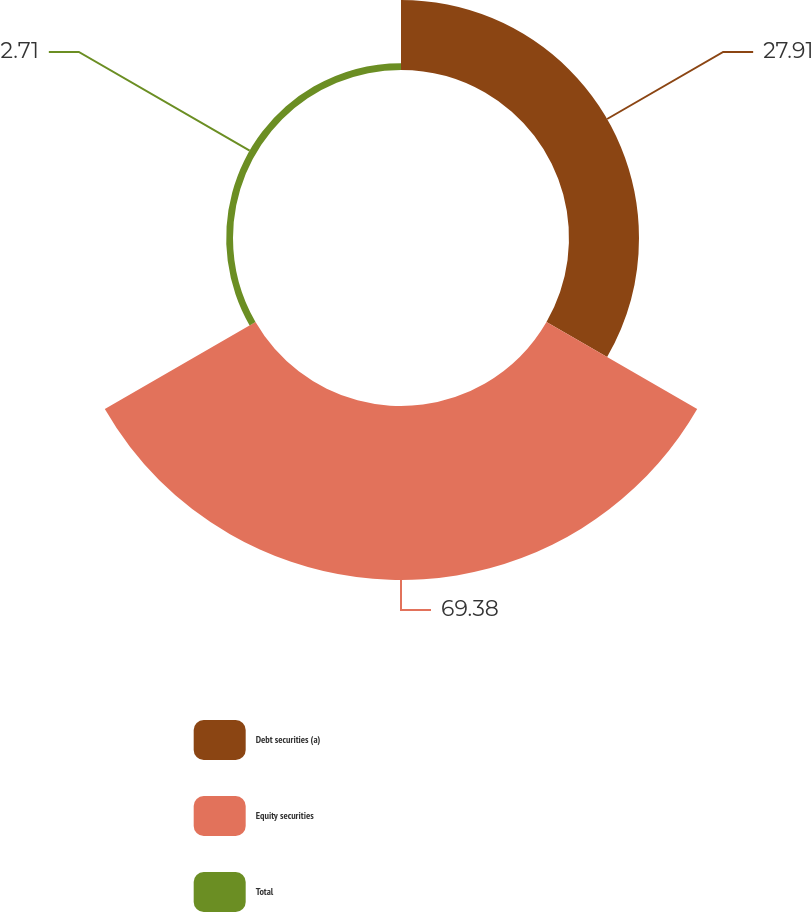Convert chart. <chart><loc_0><loc_0><loc_500><loc_500><pie_chart><fcel>Debt securities (a)<fcel>Equity securities<fcel>Total<nl><fcel>27.91%<fcel>69.38%<fcel>2.71%<nl></chart> 